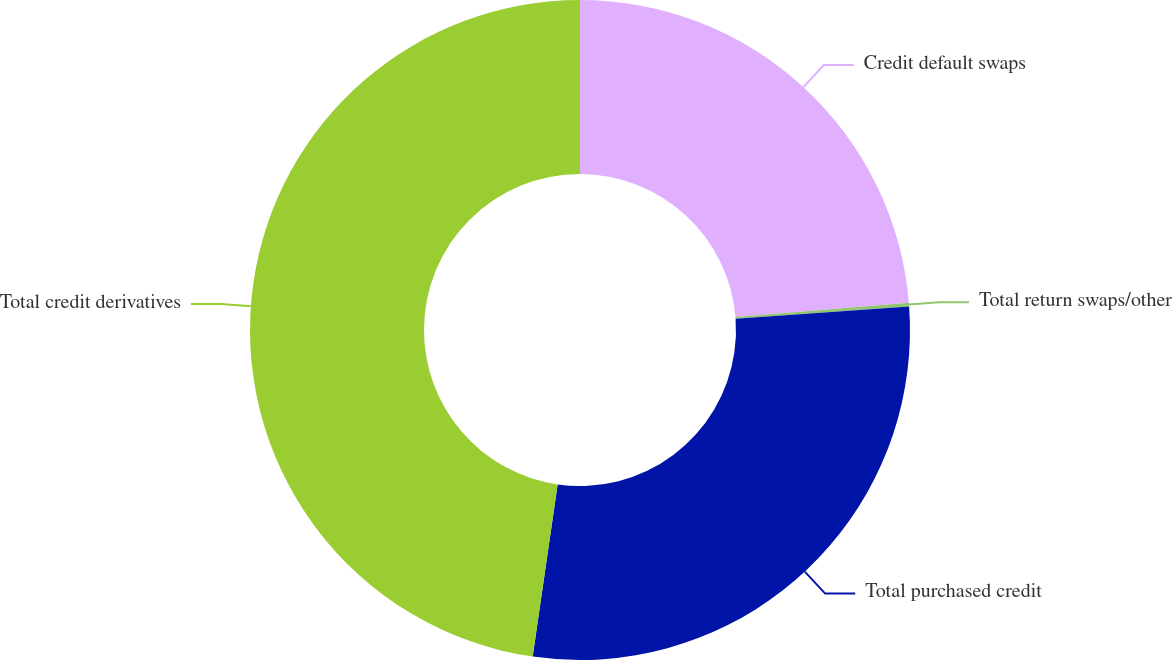<chart> <loc_0><loc_0><loc_500><loc_500><pie_chart><fcel>Credit default swaps<fcel>Total return swaps/other<fcel>Total purchased credit<fcel>Total credit derivatives<nl><fcel>23.68%<fcel>0.18%<fcel>28.43%<fcel>47.71%<nl></chart> 